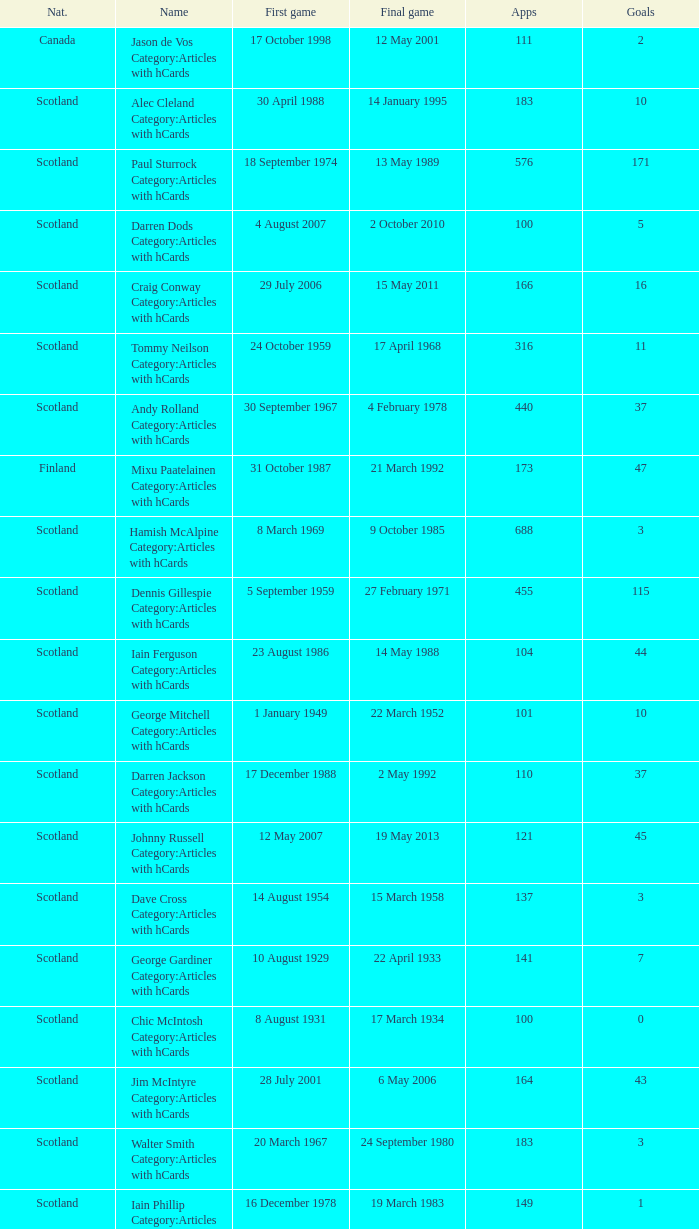What name has 118 as the apps? Ron Yeats Category:Articles with hCards. 